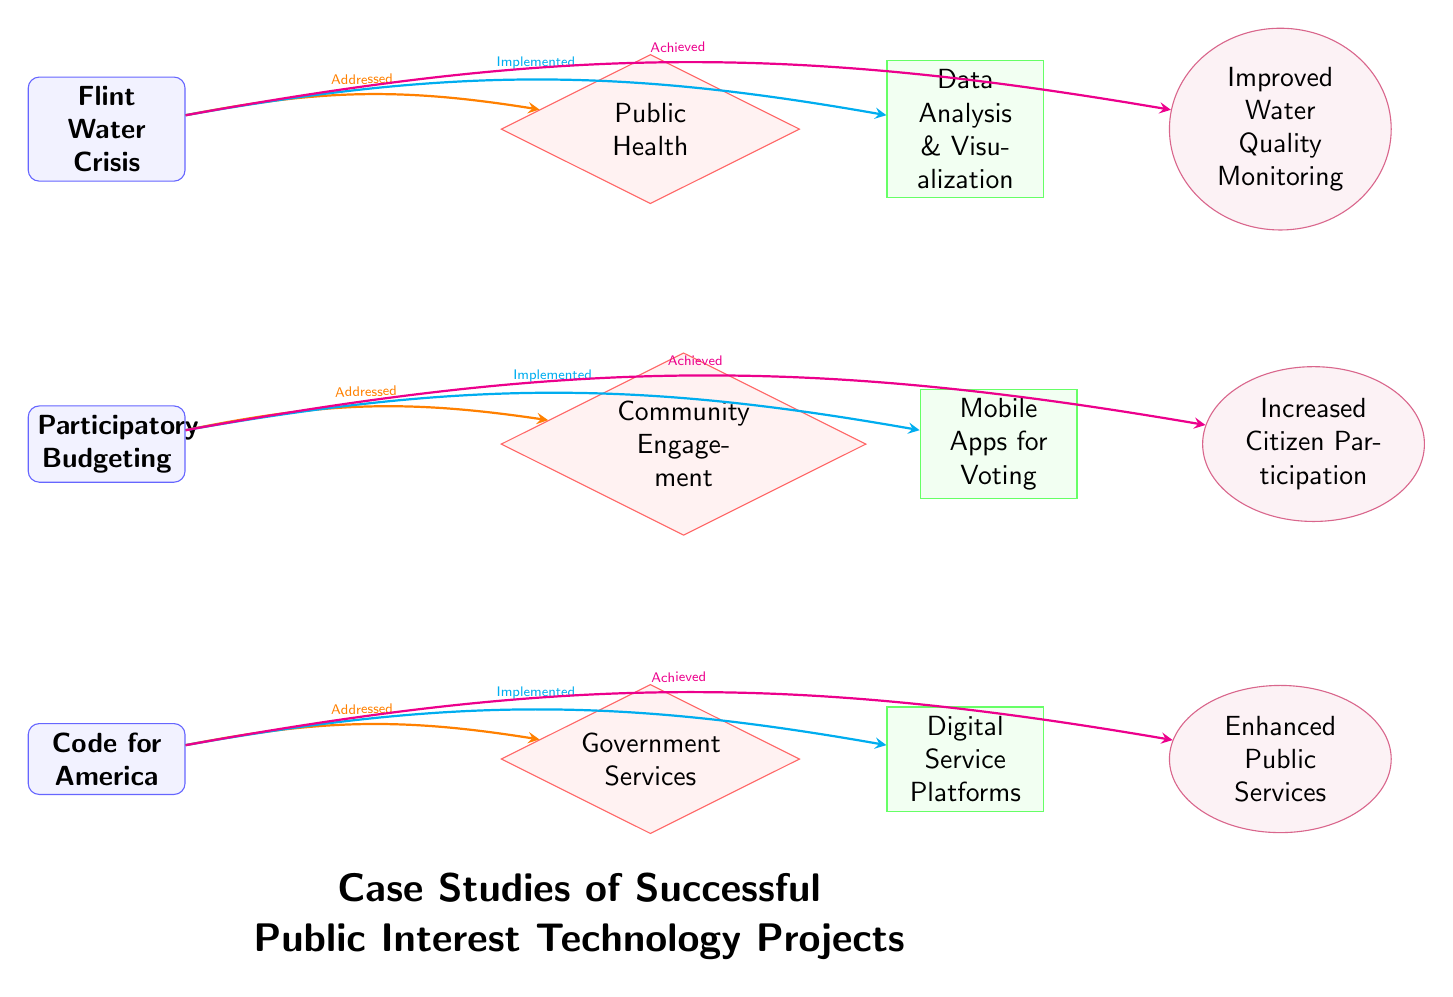What is the first case study listed in the diagram? The first case study is represented at the top of the diagram. It is labeled as "Flint Water Crisis".
Answer: Flint Water Crisis How many case studies are presented in this diagram? The diagram shows a total of three case studies, which are "Flint Water Crisis", "Participatory Budgeting", and "Code for America".
Answer: 3 Which problem is connected to the case study "Participatory Budgeting"? The problem connected to "Participatory Budgeting" is represented with a diamond shape to the right of the case study and is labeled as "Community Engagement".
Answer: Community Engagement What solution is implemented for the "Flint Water Crisis"? The solution connected to the "Flint Water Crisis" case study is identified as "Data Analysis & Visualization", which is placed to the right of the corresponding problem.
Answer: Data Analysis & Visualization What result does the "Code for America" project aim to achieve? The result achieved by the "Code for America" project, which is indicated in the oval shape at the end of its flow, is labeled as "Enhanced Public Services".
Answer: Enhanced Public Services Which color represents the problems in the diagram? The problems in the diagram are represented with a diamond shape filled in with red; this color denotes the problems.
Answer: Red How many connections are there stemming from each case study to the corresponding problem? Each case study has a single connection to its problem, hence there is one connection from each of the three case studies highlighted in the diagram.
Answer: 1 Which case study addresses public health? The case study that addresses public health is labeled as "Flint Water Crisis", which is directly connected to its specific problem related to public health.
Answer: Flint Water Crisis How is citizen participation increased according to the diagram? The diagram shows that citizen participation is increased through the implementation of "Mobile Apps for Voting" as the solution for "Participatory Budgeting".
Answer: Mobile Apps for Voting 